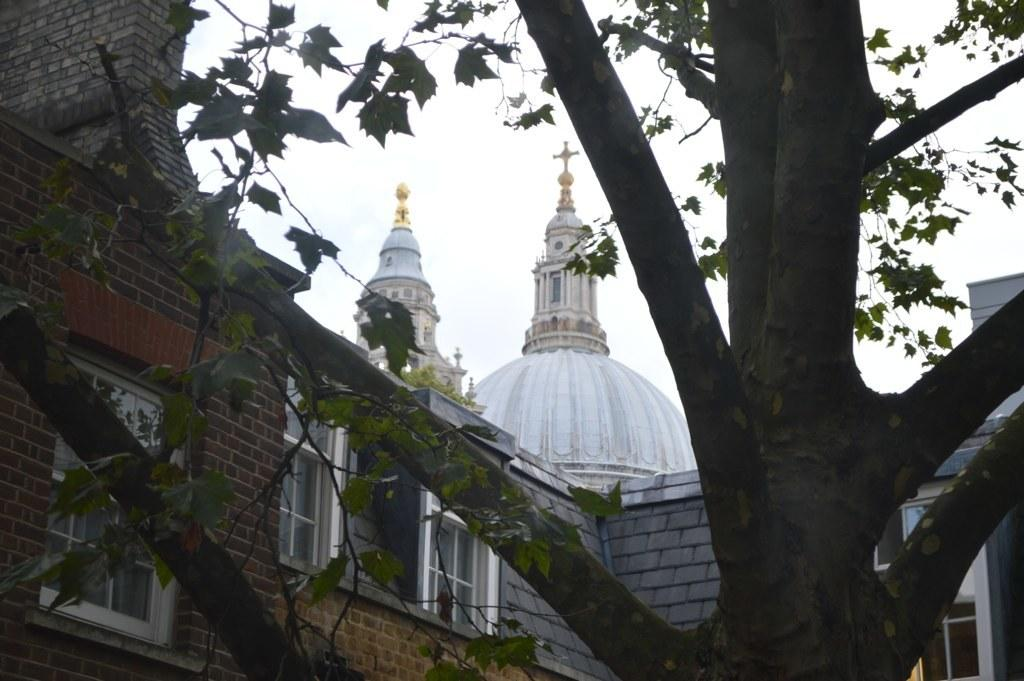What is located at the front of the image? There is a tree in the front of the image. What can be seen in the background of the image? There is a building in the background of the image. What feature of the building is mentioned in the facts? The building has windows. What is visible at the top of the image? The sky is visible at the top of the image. What is the lowest point of the tree in the image? The facts provided do not give information about the height or lowest point of the tree, so it cannot be determined from the image. Where is the base of the building located in the image? The facts provided do not give information about the base of the building, so it cannot be determined from the image. 